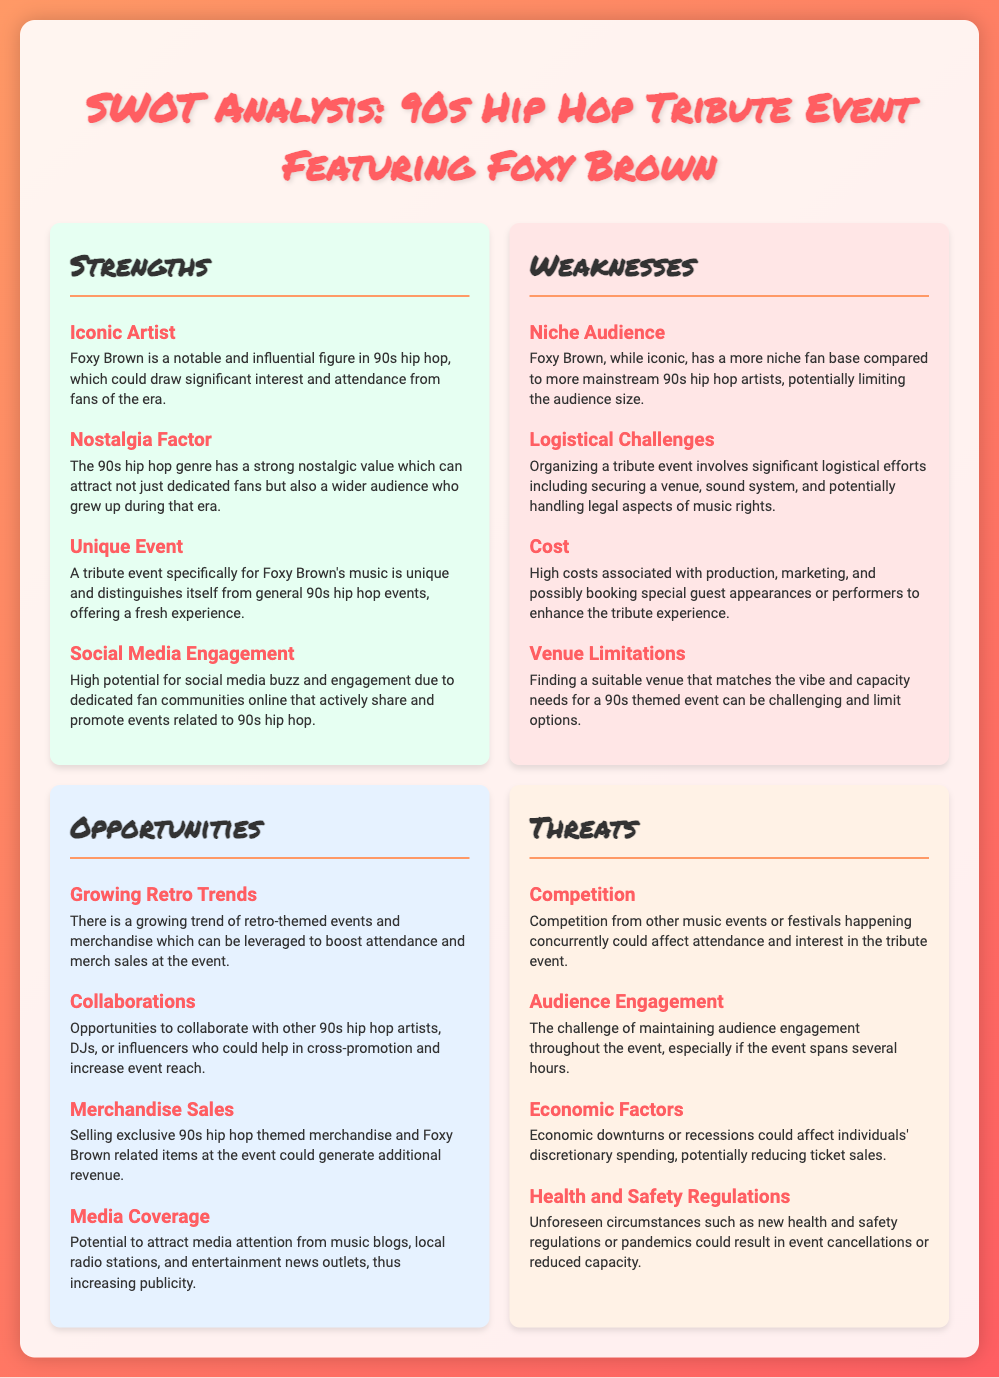What are the strengths listed in the document? The strengths include iconic artist, nostalgia factor, unique event, and social media engagement.
Answer: Iconic Artist, Nostalgia Factor, Unique Event, Social Media Engagement What is one logistical challenge mentioned? The document lists logistical challenges associated with organizing the event, highlighting the need for a venue, sound system, etc.
Answer: Securing a venue How many opportunities are identified in the document? The document explicitly lists four opportunities related to the event.
Answer: Four Who is the focal artist for the tribute event? The document specifically centers on Foxy Brown as the most significant artist of the event.
Answer: Foxy Brown What economic factor is mentioned as a potential threat? The document includes economic downturns or recessions as factors that could affect ticket sales.
Answer: Economic downturns 